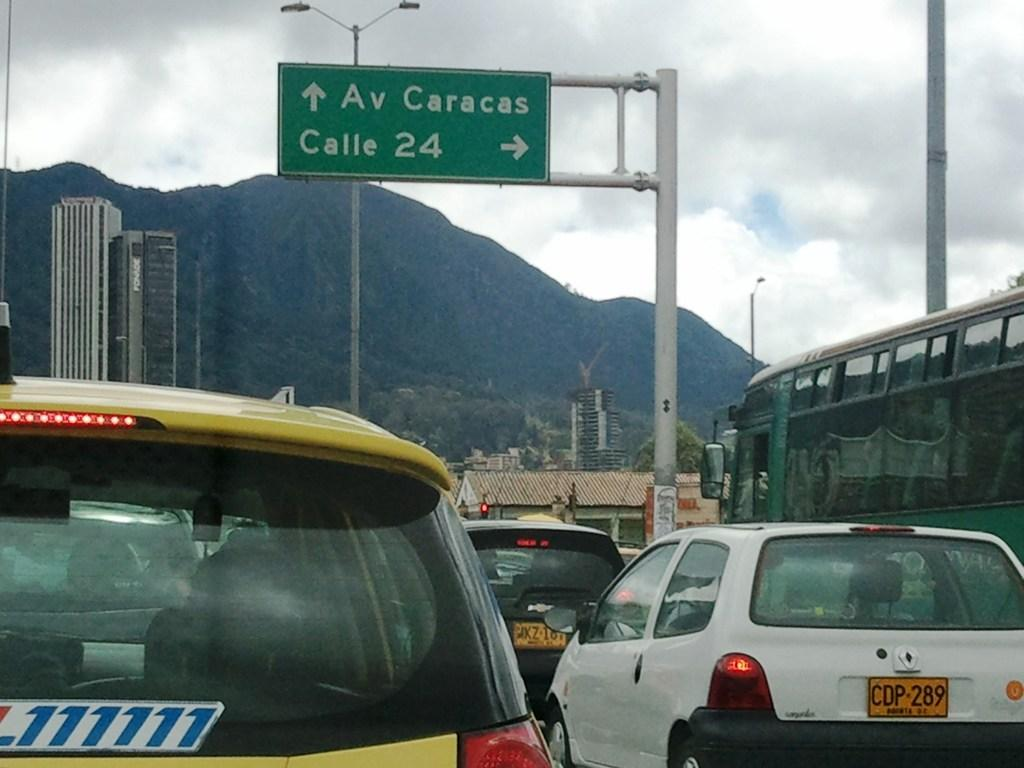What type of structures can be seen in the image? There are buildings in the image. What else is present in the image besides buildings? There are vehicles, sign boards, poles, trees, and hills in the background of the image. What can be seen at the top of the image? The sky is visible at the top of the image. What type of flock is flying over the hills in the image? There is no flock of birds or animals visible in the image; it only shows buildings, vehicles, sign boards, poles, trees, and hills in the background. What kind of smell can be detected in the lunchroom in the image? There is no lunchroom present in the image, so it is not possible to determine any smells associated with it. 